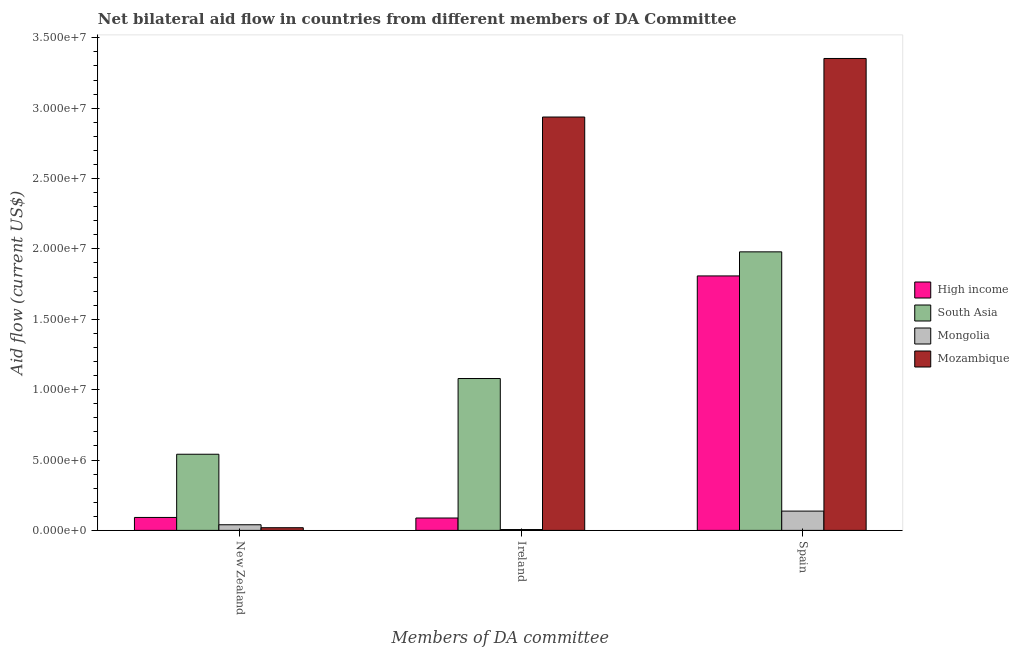How many bars are there on the 2nd tick from the left?
Offer a terse response. 4. How many bars are there on the 3rd tick from the right?
Provide a succinct answer. 4. What is the amount of aid provided by ireland in Mongolia?
Your response must be concise. 6.00e+04. Across all countries, what is the maximum amount of aid provided by ireland?
Your answer should be very brief. 2.94e+07. Across all countries, what is the minimum amount of aid provided by new zealand?
Give a very brief answer. 1.90e+05. In which country was the amount of aid provided by ireland maximum?
Provide a succinct answer. Mozambique. In which country was the amount of aid provided by new zealand minimum?
Provide a short and direct response. Mozambique. What is the total amount of aid provided by ireland in the graph?
Your answer should be compact. 4.11e+07. What is the difference between the amount of aid provided by spain in Mozambique and that in High income?
Give a very brief answer. 1.54e+07. What is the difference between the amount of aid provided by ireland in High income and the amount of aid provided by spain in Mongolia?
Your answer should be very brief. -4.90e+05. What is the average amount of aid provided by spain per country?
Give a very brief answer. 1.82e+07. What is the difference between the amount of aid provided by spain and amount of aid provided by new zealand in Mozambique?
Your answer should be very brief. 3.33e+07. In how many countries, is the amount of aid provided by new zealand greater than 30000000 US$?
Offer a terse response. 0. What is the ratio of the amount of aid provided by ireland in Mongolia to that in High income?
Offer a very short reply. 0.07. What is the difference between the highest and the second highest amount of aid provided by spain?
Make the answer very short. 1.37e+07. What is the difference between the highest and the lowest amount of aid provided by ireland?
Your response must be concise. 2.93e+07. What does the 3rd bar from the left in Ireland represents?
Give a very brief answer. Mongolia. How many bars are there?
Provide a succinct answer. 12. Are the values on the major ticks of Y-axis written in scientific E-notation?
Provide a succinct answer. Yes. Does the graph contain grids?
Offer a terse response. No. How are the legend labels stacked?
Ensure brevity in your answer.  Vertical. What is the title of the graph?
Provide a succinct answer. Net bilateral aid flow in countries from different members of DA Committee. What is the label or title of the X-axis?
Ensure brevity in your answer.  Members of DA committee. What is the Aid flow (current US$) in High income in New Zealand?
Keep it short and to the point. 9.20e+05. What is the Aid flow (current US$) in South Asia in New Zealand?
Keep it short and to the point. 5.41e+06. What is the Aid flow (current US$) in Mongolia in New Zealand?
Provide a short and direct response. 4.00e+05. What is the Aid flow (current US$) in Mozambique in New Zealand?
Make the answer very short. 1.90e+05. What is the Aid flow (current US$) in High income in Ireland?
Your response must be concise. 8.80e+05. What is the Aid flow (current US$) in South Asia in Ireland?
Offer a very short reply. 1.08e+07. What is the Aid flow (current US$) of Mozambique in Ireland?
Give a very brief answer. 2.94e+07. What is the Aid flow (current US$) of High income in Spain?
Your response must be concise. 1.81e+07. What is the Aid flow (current US$) of South Asia in Spain?
Your answer should be very brief. 1.98e+07. What is the Aid flow (current US$) of Mongolia in Spain?
Your response must be concise. 1.37e+06. What is the Aid flow (current US$) of Mozambique in Spain?
Your answer should be compact. 3.35e+07. Across all Members of DA committee, what is the maximum Aid flow (current US$) in High income?
Make the answer very short. 1.81e+07. Across all Members of DA committee, what is the maximum Aid flow (current US$) in South Asia?
Offer a terse response. 1.98e+07. Across all Members of DA committee, what is the maximum Aid flow (current US$) of Mongolia?
Give a very brief answer. 1.37e+06. Across all Members of DA committee, what is the maximum Aid flow (current US$) of Mozambique?
Your response must be concise. 3.35e+07. Across all Members of DA committee, what is the minimum Aid flow (current US$) in High income?
Your answer should be very brief. 8.80e+05. Across all Members of DA committee, what is the minimum Aid flow (current US$) of South Asia?
Your answer should be compact. 5.41e+06. Across all Members of DA committee, what is the minimum Aid flow (current US$) of Mongolia?
Give a very brief answer. 6.00e+04. Across all Members of DA committee, what is the minimum Aid flow (current US$) of Mozambique?
Ensure brevity in your answer.  1.90e+05. What is the total Aid flow (current US$) in High income in the graph?
Provide a short and direct response. 1.99e+07. What is the total Aid flow (current US$) in South Asia in the graph?
Ensure brevity in your answer.  3.60e+07. What is the total Aid flow (current US$) of Mongolia in the graph?
Provide a succinct answer. 1.83e+06. What is the total Aid flow (current US$) in Mozambique in the graph?
Ensure brevity in your answer.  6.31e+07. What is the difference between the Aid flow (current US$) of High income in New Zealand and that in Ireland?
Provide a short and direct response. 4.00e+04. What is the difference between the Aid flow (current US$) in South Asia in New Zealand and that in Ireland?
Ensure brevity in your answer.  -5.38e+06. What is the difference between the Aid flow (current US$) of Mozambique in New Zealand and that in Ireland?
Your answer should be compact. -2.92e+07. What is the difference between the Aid flow (current US$) in High income in New Zealand and that in Spain?
Your answer should be compact. -1.72e+07. What is the difference between the Aid flow (current US$) of South Asia in New Zealand and that in Spain?
Provide a succinct answer. -1.44e+07. What is the difference between the Aid flow (current US$) in Mongolia in New Zealand and that in Spain?
Your answer should be compact. -9.70e+05. What is the difference between the Aid flow (current US$) in Mozambique in New Zealand and that in Spain?
Your response must be concise. -3.33e+07. What is the difference between the Aid flow (current US$) of High income in Ireland and that in Spain?
Keep it short and to the point. -1.72e+07. What is the difference between the Aid flow (current US$) of South Asia in Ireland and that in Spain?
Provide a succinct answer. -9.00e+06. What is the difference between the Aid flow (current US$) in Mongolia in Ireland and that in Spain?
Make the answer very short. -1.31e+06. What is the difference between the Aid flow (current US$) of Mozambique in Ireland and that in Spain?
Ensure brevity in your answer.  -4.16e+06. What is the difference between the Aid flow (current US$) in High income in New Zealand and the Aid flow (current US$) in South Asia in Ireland?
Provide a short and direct response. -9.87e+06. What is the difference between the Aid flow (current US$) of High income in New Zealand and the Aid flow (current US$) of Mongolia in Ireland?
Offer a terse response. 8.60e+05. What is the difference between the Aid flow (current US$) of High income in New Zealand and the Aid flow (current US$) of Mozambique in Ireland?
Ensure brevity in your answer.  -2.84e+07. What is the difference between the Aid flow (current US$) of South Asia in New Zealand and the Aid flow (current US$) of Mongolia in Ireland?
Keep it short and to the point. 5.35e+06. What is the difference between the Aid flow (current US$) of South Asia in New Zealand and the Aid flow (current US$) of Mozambique in Ireland?
Offer a very short reply. -2.40e+07. What is the difference between the Aid flow (current US$) of Mongolia in New Zealand and the Aid flow (current US$) of Mozambique in Ireland?
Your response must be concise. -2.90e+07. What is the difference between the Aid flow (current US$) in High income in New Zealand and the Aid flow (current US$) in South Asia in Spain?
Give a very brief answer. -1.89e+07. What is the difference between the Aid flow (current US$) in High income in New Zealand and the Aid flow (current US$) in Mongolia in Spain?
Your answer should be very brief. -4.50e+05. What is the difference between the Aid flow (current US$) in High income in New Zealand and the Aid flow (current US$) in Mozambique in Spain?
Provide a short and direct response. -3.26e+07. What is the difference between the Aid flow (current US$) in South Asia in New Zealand and the Aid flow (current US$) in Mongolia in Spain?
Your response must be concise. 4.04e+06. What is the difference between the Aid flow (current US$) of South Asia in New Zealand and the Aid flow (current US$) of Mozambique in Spain?
Offer a terse response. -2.81e+07. What is the difference between the Aid flow (current US$) in Mongolia in New Zealand and the Aid flow (current US$) in Mozambique in Spain?
Your answer should be compact. -3.31e+07. What is the difference between the Aid flow (current US$) in High income in Ireland and the Aid flow (current US$) in South Asia in Spain?
Your response must be concise. -1.89e+07. What is the difference between the Aid flow (current US$) in High income in Ireland and the Aid flow (current US$) in Mongolia in Spain?
Provide a short and direct response. -4.90e+05. What is the difference between the Aid flow (current US$) of High income in Ireland and the Aid flow (current US$) of Mozambique in Spain?
Give a very brief answer. -3.26e+07. What is the difference between the Aid flow (current US$) in South Asia in Ireland and the Aid flow (current US$) in Mongolia in Spain?
Provide a short and direct response. 9.42e+06. What is the difference between the Aid flow (current US$) in South Asia in Ireland and the Aid flow (current US$) in Mozambique in Spain?
Provide a succinct answer. -2.27e+07. What is the difference between the Aid flow (current US$) of Mongolia in Ireland and the Aid flow (current US$) of Mozambique in Spain?
Give a very brief answer. -3.35e+07. What is the average Aid flow (current US$) of High income per Members of DA committee?
Keep it short and to the point. 6.63e+06. What is the average Aid flow (current US$) in South Asia per Members of DA committee?
Provide a succinct answer. 1.20e+07. What is the average Aid flow (current US$) in Mozambique per Members of DA committee?
Give a very brief answer. 2.10e+07. What is the difference between the Aid flow (current US$) in High income and Aid flow (current US$) in South Asia in New Zealand?
Offer a terse response. -4.49e+06. What is the difference between the Aid flow (current US$) in High income and Aid flow (current US$) in Mongolia in New Zealand?
Give a very brief answer. 5.20e+05. What is the difference between the Aid flow (current US$) of High income and Aid flow (current US$) of Mozambique in New Zealand?
Offer a very short reply. 7.30e+05. What is the difference between the Aid flow (current US$) of South Asia and Aid flow (current US$) of Mongolia in New Zealand?
Provide a succinct answer. 5.01e+06. What is the difference between the Aid flow (current US$) in South Asia and Aid flow (current US$) in Mozambique in New Zealand?
Give a very brief answer. 5.22e+06. What is the difference between the Aid flow (current US$) in Mongolia and Aid flow (current US$) in Mozambique in New Zealand?
Provide a short and direct response. 2.10e+05. What is the difference between the Aid flow (current US$) of High income and Aid flow (current US$) of South Asia in Ireland?
Ensure brevity in your answer.  -9.91e+06. What is the difference between the Aid flow (current US$) in High income and Aid flow (current US$) in Mongolia in Ireland?
Keep it short and to the point. 8.20e+05. What is the difference between the Aid flow (current US$) in High income and Aid flow (current US$) in Mozambique in Ireland?
Make the answer very short. -2.85e+07. What is the difference between the Aid flow (current US$) in South Asia and Aid flow (current US$) in Mongolia in Ireland?
Keep it short and to the point. 1.07e+07. What is the difference between the Aid flow (current US$) in South Asia and Aid flow (current US$) in Mozambique in Ireland?
Give a very brief answer. -1.86e+07. What is the difference between the Aid flow (current US$) in Mongolia and Aid flow (current US$) in Mozambique in Ireland?
Provide a succinct answer. -2.93e+07. What is the difference between the Aid flow (current US$) of High income and Aid flow (current US$) of South Asia in Spain?
Provide a succinct answer. -1.71e+06. What is the difference between the Aid flow (current US$) in High income and Aid flow (current US$) in Mongolia in Spain?
Ensure brevity in your answer.  1.67e+07. What is the difference between the Aid flow (current US$) in High income and Aid flow (current US$) in Mozambique in Spain?
Ensure brevity in your answer.  -1.54e+07. What is the difference between the Aid flow (current US$) in South Asia and Aid flow (current US$) in Mongolia in Spain?
Make the answer very short. 1.84e+07. What is the difference between the Aid flow (current US$) of South Asia and Aid flow (current US$) of Mozambique in Spain?
Give a very brief answer. -1.37e+07. What is the difference between the Aid flow (current US$) in Mongolia and Aid flow (current US$) in Mozambique in Spain?
Offer a terse response. -3.22e+07. What is the ratio of the Aid flow (current US$) in High income in New Zealand to that in Ireland?
Offer a very short reply. 1.05. What is the ratio of the Aid flow (current US$) of South Asia in New Zealand to that in Ireland?
Your answer should be compact. 0.5. What is the ratio of the Aid flow (current US$) in Mozambique in New Zealand to that in Ireland?
Give a very brief answer. 0.01. What is the ratio of the Aid flow (current US$) in High income in New Zealand to that in Spain?
Provide a short and direct response. 0.05. What is the ratio of the Aid flow (current US$) in South Asia in New Zealand to that in Spain?
Give a very brief answer. 0.27. What is the ratio of the Aid flow (current US$) of Mongolia in New Zealand to that in Spain?
Offer a very short reply. 0.29. What is the ratio of the Aid flow (current US$) of Mozambique in New Zealand to that in Spain?
Provide a short and direct response. 0.01. What is the ratio of the Aid flow (current US$) of High income in Ireland to that in Spain?
Offer a very short reply. 0.05. What is the ratio of the Aid flow (current US$) in South Asia in Ireland to that in Spain?
Your answer should be compact. 0.55. What is the ratio of the Aid flow (current US$) in Mongolia in Ireland to that in Spain?
Ensure brevity in your answer.  0.04. What is the ratio of the Aid flow (current US$) in Mozambique in Ireland to that in Spain?
Give a very brief answer. 0.88. What is the difference between the highest and the second highest Aid flow (current US$) of High income?
Make the answer very short. 1.72e+07. What is the difference between the highest and the second highest Aid flow (current US$) in South Asia?
Provide a short and direct response. 9.00e+06. What is the difference between the highest and the second highest Aid flow (current US$) in Mongolia?
Your answer should be compact. 9.70e+05. What is the difference between the highest and the second highest Aid flow (current US$) in Mozambique?
Keep it short and to the point. 4.16e+06. What is the difference between the highest and the lowest Aid flow (current US$) in High income?
Give a very brief answer. 1.72e+07. What is the difference between the highest and the lowest Aid flow (current US$) of South Asia?
Give a very brief answer. 1.44e+07. What is the difference between the highest and the lowest Aid flow (current US$) in Mongolia?
Make the answer very short. 1.31e+06. What is the difference between the highest and the lowest Aid flow (current US$) in Mozambique?
Your answer should be compact. 3.33e+07. 